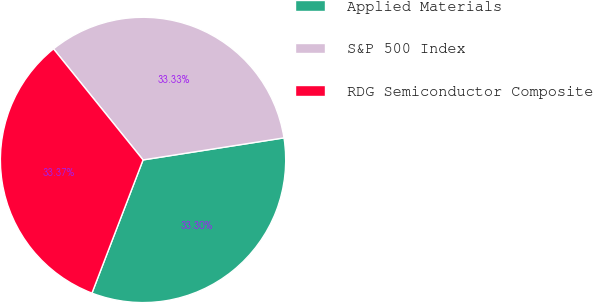Convert chart to OTSL. <chart><loc_0><loc_0><loc_500><loc_500><pie_chart><fcel>Applied Materials<fcel>S&P 500 Index<fcel>RDG Semiconductor Composite<nl><fcel>33.3%<fcel>33.33%<fcel>33.37%<nl></chart> 